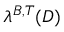Convert formula to latex. <formula><loc_0><loc_0><loc_500><loc_500>\lambda ^ { B , T } ( D )</formula> 